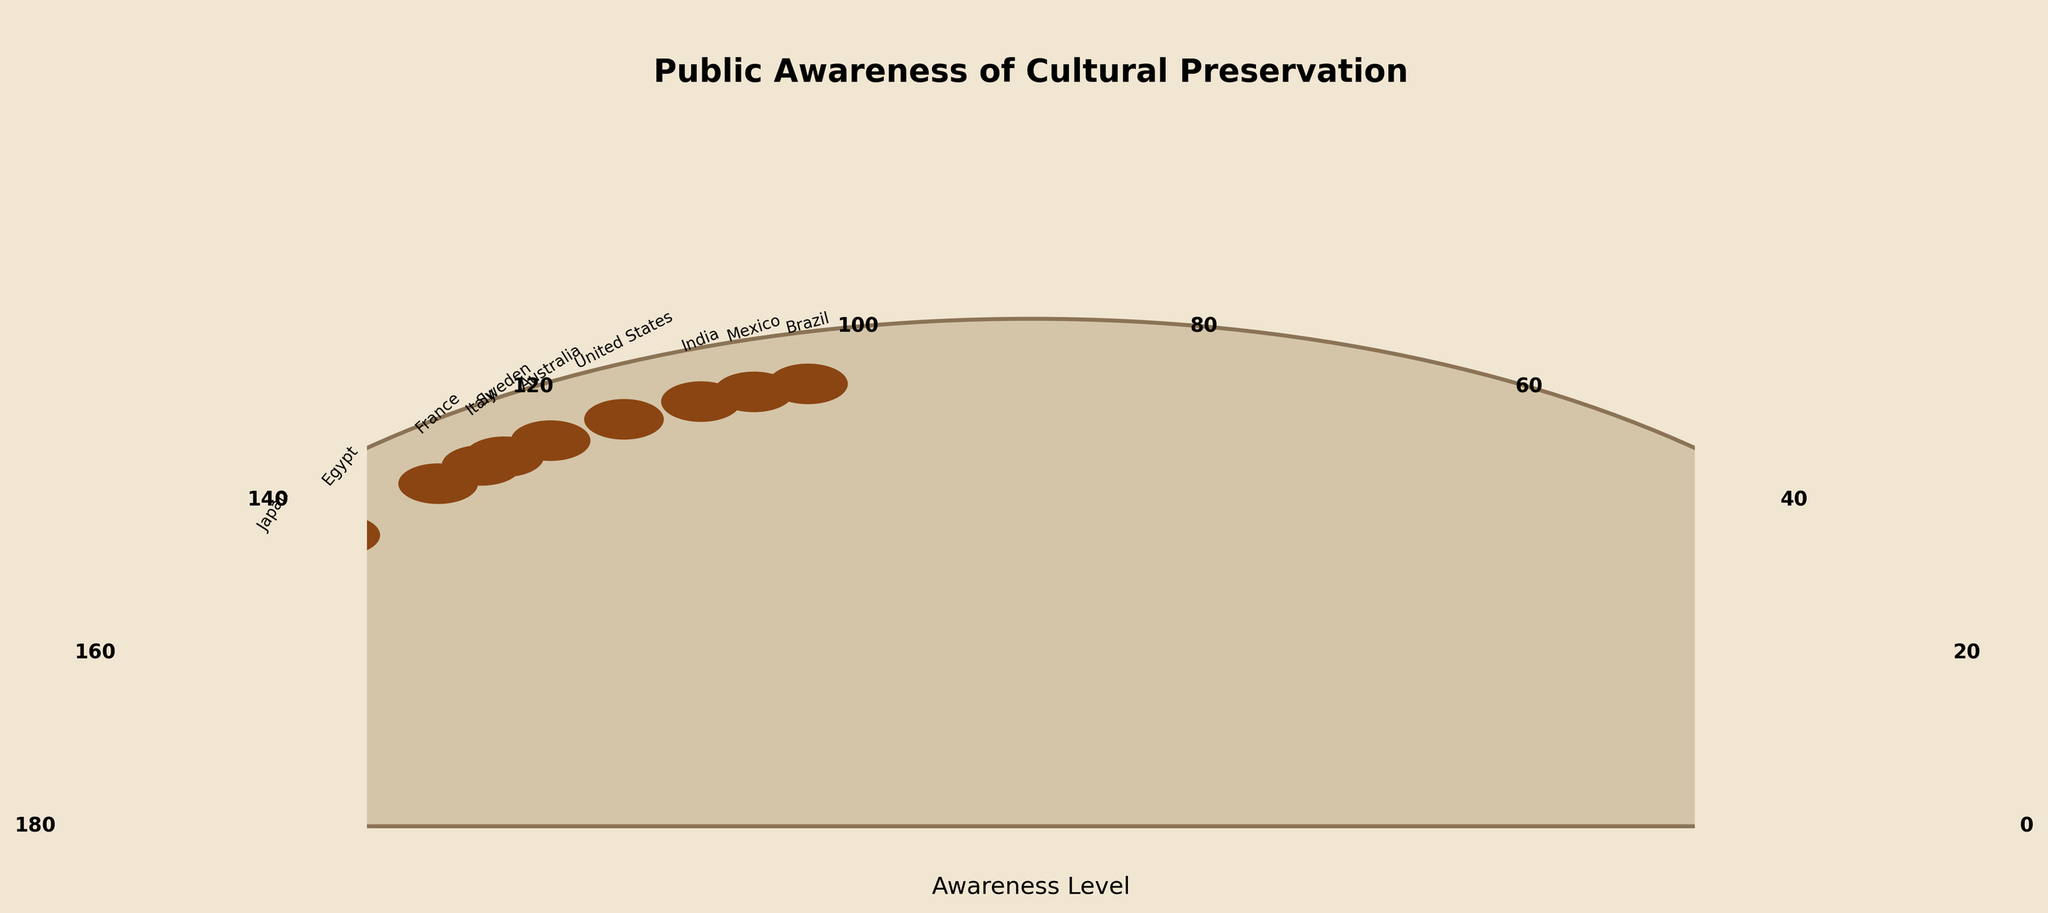What is the title of the figure? The title is usually positioned at the top of the figure and provides an overall description of the visual representation. In this case, it is labeled clearly above the gauge.
Answer: Public Awareness of Cultural Preservation What color is used for the background of the gauge? The background color is a visual element that sets the context for the data points on the gauge. In this situation, the gauge background has a specific shading.
Answer: Light beige or '#D4C5A8' How many regions are represented in the figure? The number of regions can be counted by looking at the number of labeled data points on the gauge chart. Each data point corresponds to a region.
Answer: 10 Which region has the highest awareness level? The highest awareness level can be identified by locating the data point that is placed furthest to the right (nearest to the 180-degree mark) on the gauge chart.
Answer: Japan What is the awareness level of Mexico? The awareness level for Mexico can be identified by locating its labeled data point on the gauge chart and reading the corresponding value near the tick marks.
Answer: 60 Which region is closer to an awareness level of 80, Egypt or France? To determine proximity, compare the positions of the Egypt and France data points on the gauge with their distances to the 80 mark.
Answer: Egypt What is the average awareness level across all regions? Add up all the awareness levels for each region and divide by the total number of regions to calculate the average. The values are (65+82+78+73+70+58+62+68+71+60)/10 = 68.7.
Answer: 68.7 Which region has the lowest awareness level? The lowest awareness level can be identified by finding the data point placed furthest to the left (nearest to the 0-degree mark) on the gauge chart.
Answer: Brazil How many regions have an awareness level above 70? Count the number of data points whose values position them above the 70 tick mark on the gauge chart.
Answer: 4 Is the awareness level for Italy greater than or equal to the awareness level for Sweden? Compare the placement of the labeled data points for Italy and Sweden on the gauge chart and see if Italy’s mark is at or beyond Sweden’s.
Answer: Yes 